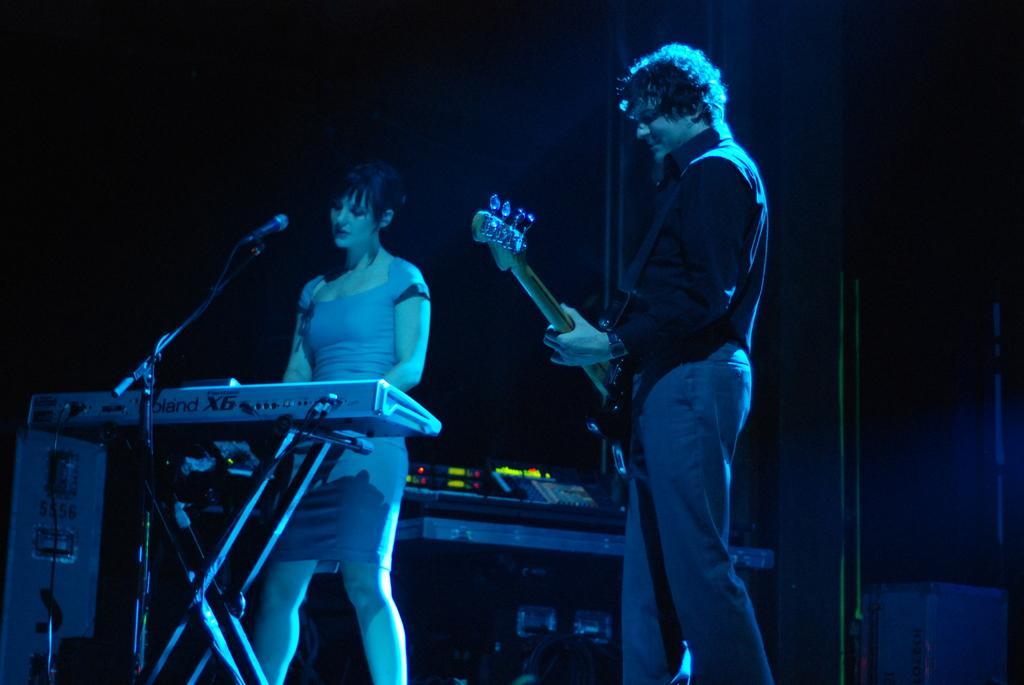Can you describe this image briefly? It is a music concert,the are two people a man and woman , man is holding guitar around his shoulders , he is turning towards his left side, the woman is playing piano there is a mike in front of her , behind them there is a music system, there is a blue color light falling on them , in the background it is completely black color. 